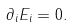<formula> <loc_0><loc_0><loc_500><loc_500>\partial _ { i } E _ { i } = 0 .</formula> 